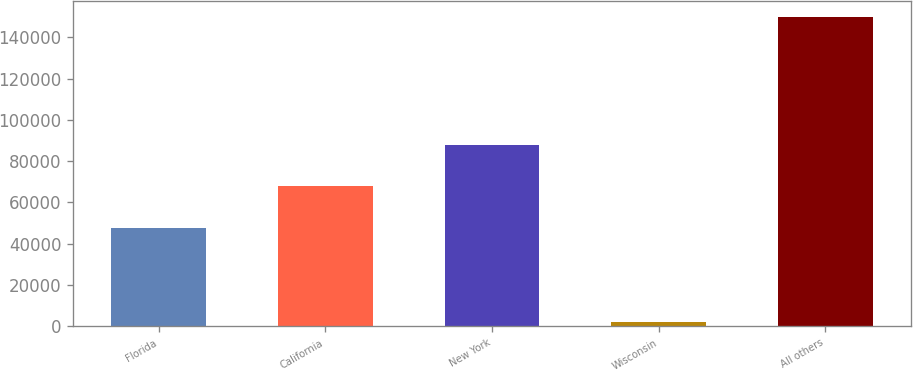<chart> <loc_0><loc_0><loc_500><loc_500><bar_chart><fcel>Florida<fcel>California<fcel>New York<fcel>Wisconsin<fcel>All others<nl><fcel>47378<fcel>67662<fcel>88004<fcel>1998<fcel>149949<nl></chart> 